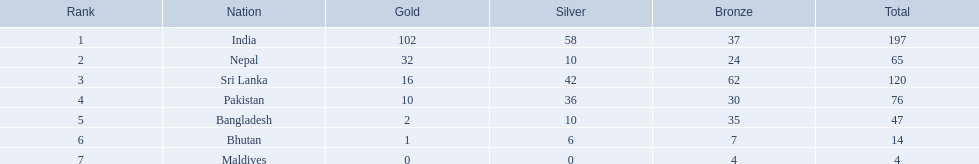What are the totals of medals one in each country? 197, 65, 120, 76, 47, 14, 4. Which of these totals are less than 10? 4. Who won this number of medals? Maldives. In which countries were medals achieved? India, Nepal, Sri Lanka, Pakistan, Bangladesh, Bhutan, Maldives. Which achieved the highest number? India. Which achieved the lowest number? Maldives. 